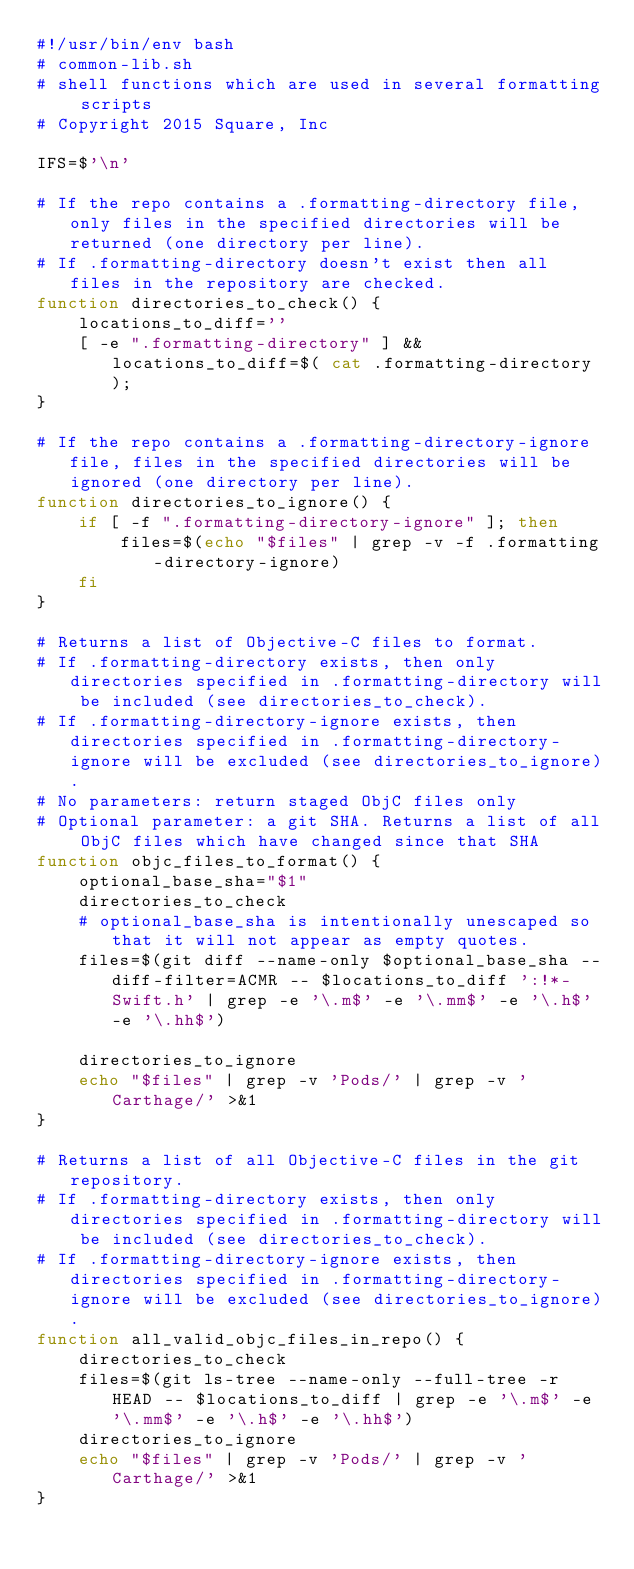Convert code to text. <code><loc_0><loc_0><loc_500><loc_500><_Bash_>#!/usr/bin/env bash
# common-lib.sh
# shell functions which are used in several formatting scripts
# Copyright 2015 Square, Inc

IFS=$'\n'

# If the repo contains a .formatting-directory file, only files in the specified directories will be returned (one directory per line).
# If .formatting-directory doesn't exist then all files in the repository are checked.
function directories_to_check() {
	locations_to_diff=''
	[ -e ".formatting-directory" ] && locations_to_diff=$( cat .formatting-directory );
}

# If the repo contains a .formatting-directory-ignore file, files in the specified directories will be ignored (one directory per line).
function directories_to_ignore() {
	if [ -f ".formatting-directory-ignore" ]; then
		files=$(echo "$files" | grep -v -f .formatting-directory-ignore)
	fi
}

# Returns a list of Objective-C files to format.
# If .formatting-directory exists, then only directories specified in .formatting-directory will be included (see directories_to_check).
# If .formatting-directory-ignore exists, then directories specified in .formatting-directory-ignore will be excluded (see directories_to_ignore).
# No parameters: return staged ObjC files only
# Optional parameter: a git SHA. Returns a list of all ObjC files which have changed since that SHA
function objc_files_to_format() {
	optional_base_sha="$1"
	directories_to_check
	# optional_base_sha is intentionally unescaped so that it will not appear as empty quotes.
	files=$(git diff --name-only $optional_base_sha --diff-filter=ACMR -- $locations_to_diff ':!*-Swift.h' | grep -e '\.m$' -e '\.mm$' -e '\.h$' -e '\.hh$')

	directories_to_ignore
	echo "$files" | grep -v 'Pods/' | grep -v 'Carthage/' >&1
}

# Returns a list of all Objective-C files in the git repository.
# If .formatting-directory exists, then only directories specified in .formatting-directory will be included (see directories_to_check).
# If .formatting-directory-ignore exists, then directories specified in .formatting-directory-ignore will be excluded (see directories_to_ignore). 
function all_valid_objc_files_in_repo() {
	directories_to_check
	files=$(git ls-tree --name-only --full-tree -r HEAD -- $locations_to_diff | grep -e '\.m$' -e '\.mm$' -e '\.h$' -e '\.hh$')
	directories_to_ignore
	echo "$files" | grep -v 'Pods/' | grep -v 'Carthage/' >&1
}
</code> 